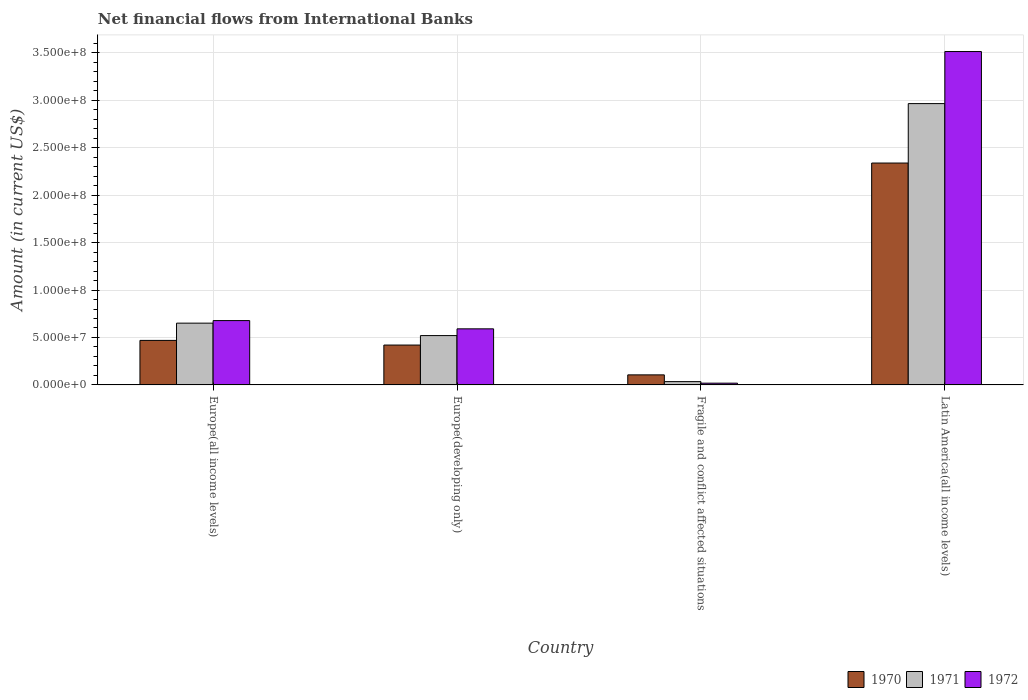How many different coloured bars are there?
Provide a short and direct response. 3. How many groups of bars are there?
Your answer should be compact. 4. Are the number of bars per tick equal to the number of legend labels?
Make the answer very short. Yes. Are the number of bars on each tick of the X-axis equal?
Your response must be concise. Yes. What is the label of the 3rd group of bars from the left?
Provide a short and direct response. Fragile and conflict affected situations. In how many cases, is the number of bars for a given country not equal to the number of legend labels?
Your answer should be compact. 0. What is the net financial aid flows in 1970 in Latin America(all income levels)?
Provide a succinct answer. 2.34e+08. Across all countries, what is the maximum net financial aid flows in 1972?
Your answer should be compact. 3.51e+08. Across all countries, what is the minimum net financial aid flows in 1970?
Your answer should be compact. 1.06e+07. In which country was the net financial aid flows in 1971 maximum?
Make the answer very short. Latin America(all income levels). In which country was the net financial aid flows in 1971 minimum?
Provide a succinct answer. Fragile and conflict affected situations. What is the total net financial aid flows in 1971 in the graph?
Give a very brief answer. 4.17e+08. What is the difference between the net financial aid flows in 1970 in Europe(developing only) and that in Fragile and conflict affected situations?
Provide a short and direct response. 3.14e+07. What is the difference between the net financial aid flows in 1972 in Europe(developing only) and the net financial aid flows in 1970 in Latin America(all income levels)?
Provide a succinct answer. -1.75e+08. What is the average net financial aid flows in 1972 per country?
Ensure brevity in your answer.  1.20e+08. What is the difference between the net financial aid flows of/in 1972 and net financial aid flows of/in 1971 in Latin America(all income levels)?
Offer a very short reply. 5.49e+07. What is the ratio of the net financial aid flows in 1971 in Europe(all income levels) to that in Latin America(all income levels)?
Keep it short and to the point. 0.22. Is the net financial aid flows in 1970 in Europe(developing only) less than that in Fragile and conflict affected situations?
Provide a short and direct response. No. What is the difference between the highest and the second highest net financial aid flows in 1970?
Make the answer very short. 1.87e+08. What is the difference between the highest and the lowest net financial aid flows in 1971?
Make the answer very short. 2.93e+08. What does the 3rd bar from the right in Europe(developing only) represents?
Provide a succinct answer. 1970. Are all the bars in the graph horizontal?
Ensure brevity in your answer.  No. What is the difference between two consecutive major ticks on the Y-axis?
Provide a succinct answer. 5.00e+07. Are the values on the major ticks of Y-axis written in scientific E-notation?
Make the answer very short. Yes. Does the graph contain any zero values?
Your answer should be very brief. No. Does the graph contain grids?
Provide a short and direct response. Yes. Where does the legend appear in the graph?
Offer a very short reply. Bottom right. How many legend labels are there?
Make the answer very short. 3. How are the legend labels stacked?
Your response must be concise. Horizontal. What is the title of the graph?
Your answer should be very brief. Net financial flows from International Banks. What is the Amount (in current US$) in 1970 in Europe(all income levels)?
Your response must be concise. 4.69e+07. What is the Amount (in current US$) in 1971 in Europe(all income levels)?
Provide a succinct answer. 6.51e+07. What is the Amount (in current US$) of 1972 in Europe(all income levels)?
Provide a succinct answer. 6.78e+07. What is the Amount (in current US$) in 1970 in Europe(developing only)?
Keep it short and to the point. 4.20e+07. What is the Amount (in current US$) in 1971 in Europe(developing only)?
Offer a very short reply. 5.20e+07. What is the Amount (in current US$) in 1972 in Europe(developing only)?
Provide a short and direct response. 5.91e+07. What is the Amount (in current US$) in 1970 in Fragile and conflict affected situations?
Your response must be concise. 1.06e+07. What is the Amount (in current US$) in 1971 in Fragile and conflict affected situations?
Your answer should be compact. 3.47e+06. What is the Amount (in current US$) in 1972 in Fragile and conflict affected situations?
Your answer should be very brief. 1.85e+06. What is the Amount (in current US$) in 1970 in Latin America(all income levels)?
Provide a succinct answer. 2.34e+08. What is the Amount (in current US$) of 1971 in Latin America(all income levels)?
Your response must be concise. 2.96e+08. What is the Amount (in current US$) of 1972 in Latin America(all income levels)?
Provide a succinct answer. 3.51e+08. Across all countries, what is the maximum Amount (in current US$) of 1970?
Keep it short and to the point. 2.34e+08. Across all countries, what is the maximum Amount (in current US$) in 1971?
Your answer should be compact. 2.96e+08. Across all countries, what is the maximum Amount (in current US$) in 1972?
Make the answer very short. 3.51e+08. Across all countries, what is the minimum Amount (in current US$) in 1970?
Give a very brief answer. 1.06e+07. Across all countries, what is the minimum Amount (in current US$) of 1971?
Provide a short and direct response. 3.47e+06. Across all countries, what is the minimum Amount (in current US$) of 1972?
Ensure brevity in your answer.  1.85e+06. What is the total Amount (in current US$) of 1970 in the graph?
Ensure brevity in your answer.  3.33e+08. What is the total Amount (in current US$) of 1971 in the graph?
Your answer should be very brief. 4.17e+08. What is the total Amount (in current US$) of 1972 in the graph?
Your answer should be compact. 4.80e+08. What is the difference between the Amount (in current US$) in 1970 in Europe(all income levels) and that in Europe(developing only)?
Offer a terse response. 4.90e+06. What is the difference between the Amount (in current US$) of 1971 in Europe(all income levels) and that in Europe(developing only)?
Your response must be concise. 1.31e+07. What is the difference between the Amount (in current US$) of 1972 in Europe(all income levels) and that in Europe(developing only)?
Give a very brief answer. 8.70e+06. What is the difference between the Amount (in current US$) in 1970 in Europe(all income levels) and that in Fragile and conflict affected situations?
Your answer should be compact. 3.63e+07. What is the difference between the Amount (in current US$) in 1971 in Europe(all income levels) and that in Fragile and conflict affected situations?
Your answer should be compact. 6.16e+07. What is the difference between the Amount (in current US$) of 1972 in Europe(all income levels) and that in Fragile and conflict affected situations?
Give a very brief answer. 6.59e+07. What is the difference between the Amount (in current US$) in 1970 in Europe(all income levels) and that in Latin America(all income levels)?
Your answer should be very brief. -1.87e+08. What is the difference between the Amount (in current US$) in 1971 in Europe(all income levels) and that in Latin America(all income levels)?
Provide a succinct answer. -2.31e+08. What is the difference between the Amount (in current US$) of 1972 in Europe(all income levels) and that in Latin America(all income levels)?
Give a very brief answer. -2.84e+08. What is the difference between the Amount (in current US$) in 1970 in Europe(developing only) and that in Fragile and conflict affected situations?
Offer a very short reply. 3.14e+07. What is the difference between the Amount (in current US$) of 1971 in Europe(developing only) and that in Fragile and conflict affected situations?
Provide a succinct answer. 4.85e+07. What is the difference between the Amount (in current US$) in 1972 in Europe(developing only) and that in Fragile and conflict affected situations?
Your answer should be compact. 5.72e+07. What is the difference between the Amount (in current US$) of 1970 in Europe(developing only) and that in Latin America(all income levels)?
Ensure brevity in your answer.  -1.92e+08. What is the difference between the Amount (in current US$) of 1971 in Europe(developing only) and that in Latin America(all income levels)?
Provide a succinct answer. -2.44e+08. What is the difference between the Amount (in current US$) of 1972 in Europe(developing only) and that in Latin America(all income levels)?
Offer a very short reply. -2.92e+08. What is the difference between the Amount (in current US$) in 1970 in Fragile and conflict affected situations and that in Latin America(all income levels)?
Ensure brevity in your answer.  -2.23e+08. What is the difference between the Amount (in current US$) in 1971 in Fragile and conflict affected situations and that in Latin America(all income levels)?
Make the answer very short. -2.93e+08. What is the difference between the Amount (in current US$) in 1972 in Fragile and conflict affected situations and that in Latin America(all income levels)?
Your answer should be compact. -3.49e+08. What is the difference between the Amount (in current US$) in 1970 in Europe(all income levels) and the Amount (in current US$) in 1971 in Europe(developing only)?
Your answer should be very brief. -5.08e+06. What is the difference between the Amount (in current US$) in 1970 in Europe(all income levels) and the Amount (in current US$) in 1972 in Europe(developing only)?
Make the answer very short. -1.22e+07. What is the difference between the Amount (in current US$) of 1971 in Europe(all income levels) and the Amount (in current US$) of 1972 in Europe(developing only)?
Your answer should be compact. 6.00e+06. What is the difference between the Amount (in current US$) of 1970 in Europe(all income levels) and the Amount (in current US$) of 1971 in Fragile and conflict affected situations?
Your answer should be compact. 4.34e+07. What is the difference between the Amount (in current US$) of 1970 in Europe(all income levels) and the Amount (in current US$) of 1972 in Fragile and conflict affected situations?
Ensure brevity in your answer.  4.51e+07. What is the difference between the Amount (in current US$) of 1971 in Europe(all income levels) and the Amount (in current US$) of 1972 in Fragile and conflict affected situations?
Keep it short and to the point. 6.32e+07. What is the difference between the Amount (in current US$) of 1970 in Europe(all income levels) and the Amount (in current US$) of 1971 in Latin America(all income levels)?
Give a very brief answer. -2.50e+08. What is the difference between the Amount (in current US$) in 1970 in Europe(all income levels) and the Amount (in current US$) in 1972 in Latin America(all income levels)?
Your answer should be compact. -3.04e+08. What is the difference between the Amount (in current US$) in 1971 in Europe(all income levels) and the Amount (in current US$) in 1972 in Latin America(all income levels)?
Your answer should be very brief. -2.86e+08. What is the difference between the Amount (in current US$) of 1970 in Europe(developing only) and the Amount (in current US$) of 1971 in Fragile and conflict affected situations?
Offer a terse response. 3.85e+07. What is the difference between the Amount (in current US$) in 1970 in Europe(developing only) and the Amount (in current US$) in 1972 in Fragile and conflict affected situations?
Keep it short and to the point. 4.02e+07. What is the difference between the Amount (in current US$) in 1971 in Europe(developing only) and the Amount (in current US$) in 1972 in Fragile and conflict affected situations?
Keep it short and to the point. 5.01e+07. What is the difference between the Amount (in current US$) of 1970 in Europe(developing only) and the Amount (in current US$) of 1971 in Latin America(all income levels)?
Your answer should be compact. -2.54e+08. What is the difference between the Amount (in current US$) of 1970 in Europe(developing only) and the Amount (in current US$) of 1972 in Latin America(all income levels)?
Your answer should be compact. -3.09e+08. What is the difference between the Amount (in current US$) of 1971 in Europe(developing only) and the Amount (in current US$) of 1972 in Latin America(all income levels)?
Offer a terse response. -2.99e+08. What is the difference between the Amount (in current US$) in 1970 in Fragile and conflict affected situations and the Amount (in current US$) in 1971 in Latin America(all income levels)?
Offer a terse response. -2.86e+08. What is the difference between the Amount (in current US$) in 1970 in Fragile and conflict affected situations and the Amount (in current US$) in 1972 in Latin America(all income levels)?
Keep it short and to the point. -3.41e+08. What is the difference between the Amount (in current US$) of 1971 in Fragile and conflict affected situations and the Amount (in current US$) of 1972 in Latin America(all income levels)?
Your response must be concise. -3.48e+08. What is the average Amount (in current US$) in 1970 per country?
Your answer should be compact. 8.33e+07. What is the average Amount (in current US$) in 1971 per country?
Keep it short and to the point. 1.04e+08. What is the average Amount (in current US$) in 1972 per country?
Offer a terse response. 1.20e+08. What is the difference between the Amount (in current US$) of 1970 and Amount (in current US$) of 1971 in Europe(all income levels)?
Your answer should be compact. -1.82e+07. What is the difference between the Amount (in current US$) of 1970 and Amount (in current US$) of 1972 in Europe(all income levels)?
Your answer should be compact. -2.09e+07. What is the difference between the Amount (in current US$) in 1971 and Amount (in current US$) in 1972 in Europe(all income levels)?
Make the answer very short. -2.70e+06. What is the difference between the Amount (in current US$) of 1970 and Amount (in current US$) of 1971 in Europe(developing only)?
Offer a terse response. -9.98e+06. What is the difference between the Amount (in current US$) of 1970 and Amount (in current US$) of 1972 in Europe(developing only)?
Provide a succinct answer. -1.71e+07. What is the difference between the Amount (in current US$) in 1971 and Amount (in current US$) in 1972 in Europe(developing only)?
Provide a succinct answer. -7.10e+06. What is the difference between the Amount (in current US$) of 1970 and Amount (in current US$) of 1971 in Fragile and conflict affected situations?
Your answer should be very brief. 7.12e+06. What is the difference between the Amount (in current US$) in 1970 and Amount (in current US$) in 1972 in Fragile and conflict affected situations?
Offer a terse response. 8.74e+06. What is the difference between the Amount (in current US$) of 1971 and Amount (in current US$) of 1972 in Fragile and conflict affected situations?
Your response must be concise. 1.62e+06. What is the difference between the Amount (in current US$) of 1970 and Amount (in current US$) of 1971 in Latin America(all income levels)?
Keep it short and to the point. -6.26e+07. What is the difference between the Amount (in current US$) in 1970 and Amount (in current US$) in 1972 in Latin America(all income levels)?
Provide a short and direct response. -1.18e+08. What is the difference between the Amount (in current US$) of 1971 and Amount (in current US$) of 1972 in Latin America(all income levels)?
Offer a very short reply. -5.49e+07. What is the ratio of the Amount (in current US$) of 1970 in Europe(all income levels) to that in Europe(developing only)?
Keep it short and to the point. 1.12. What is the ratio of the Amount (in current US$) of 1971 in Europe(all income levels) to that in Europe(developing only)?
Your answer should be very brief. 1.25. What is the ratio of the Amount (in current US$) of 1972 in Europe(all income levels) to that in Europe(developing only)?
Offer a very short reply. 1.15. What is the ratio of the Amount (in current US$) of 1970 in Europe(all income levels) to that in Fragile and conflict affected situations?
Your response must be concise. 4.43. What is the ratio of the Amount (in current US$) of 1971 in Europe(all income levels) to that in Fragile and conflict affected situations?
Give a very brief answer. 18.78. What is the ratio of the Amount (in current US$) in 1972 in Europe(all income levels) to that in Fragile and conflict affected situations?
Provide a succinct answer. 36.69. What is the ratio of the Amount (in current US$) in 1970 in Europe(all income levels) to that in Latin America(all income levels)?
Offer a very short reply. 0.2. What is the ratio of the Amount (in current US$) of 1971 in Europe(all income levels) to that in Latin America(all income levels)?
Ensure brevity in your answer.  0.22. What is the ratio of the Amount (in current US$) in 1972 in Europe(all income levels) to that in Latin America(all income levels)?
Make the answer very short. 0.19. What is the ratio of the Amount (in current US$) of 1970 in Europe(developing only) to that in Fragile and conflict affected situations?
Offer a very short reply. 3.97. What is the ratio of the Amount (in current US$) of 1971 in Europe(developing only) to that in Fragile and conflict affected situations?
Your response must be concise. 15. What is the ratio of the Amount (in current US$) in 1972 in Europe(developing only) to that in Fragile and conflict affected situations?
Your answer should be compact. 31.98. What is the ratio of the Amount (in current US$) of 1970 in Europe(developing only) to that in Latin America(all income levels)?
Offer a terse response. 0.18. What is the ratio of the Amount (in current US$) of 1971 in Europe(developing only) to that in Latin America(all income levels)?
Make the answer very short. 0.18. What is the ratio of the Amount (in current US$) of 1972 in Europe(developing only) to that in Latin America(all income levels)?
Offer a terse response. 0.17. What is the ratio of the Amount (in current US$) in 1970 in Fragile and conflict affected situations to that in Latin America(all income levels)?
Provide a succinct answer. 0.05. What is the ratio of the Amount (in current US$) in 1971 in Fragile and conflict affected situations to that in Latin America(all income levels)?
Give a very brief answer. 0.01. What is the ratio of the Amount (in current US$) of 1972 in Fragile and conflict affected situations to that in Latin America(all income levels)?
Your answer should be very brief. 0.01. What is the difference between the highest and the second highest Amount (in current US$) in 1970?
Provide a succinct answer. 1.87e+08. What is the difference between the highest and the second highest Amount (in current US$) in 1971?
Your answer should be very brief. 2.31e+08. What is the difference between the highest and the second highest Amount (in current US$) of 1972?
Offer a very short reply. 2.84e+08. What is the difference between the highest and the lowest Amount (in current US$) in 1970?
Provide a short and direct response. 2.23e+08. What is the difference between the highest and the lowest Amount (in current US$) of 1971?
Offer a terse response. 2.93e+08. What is the difference between the highest and the lowest Amount (in current US$) in 1972?
Offer a very short reply. 3.49e+08. 